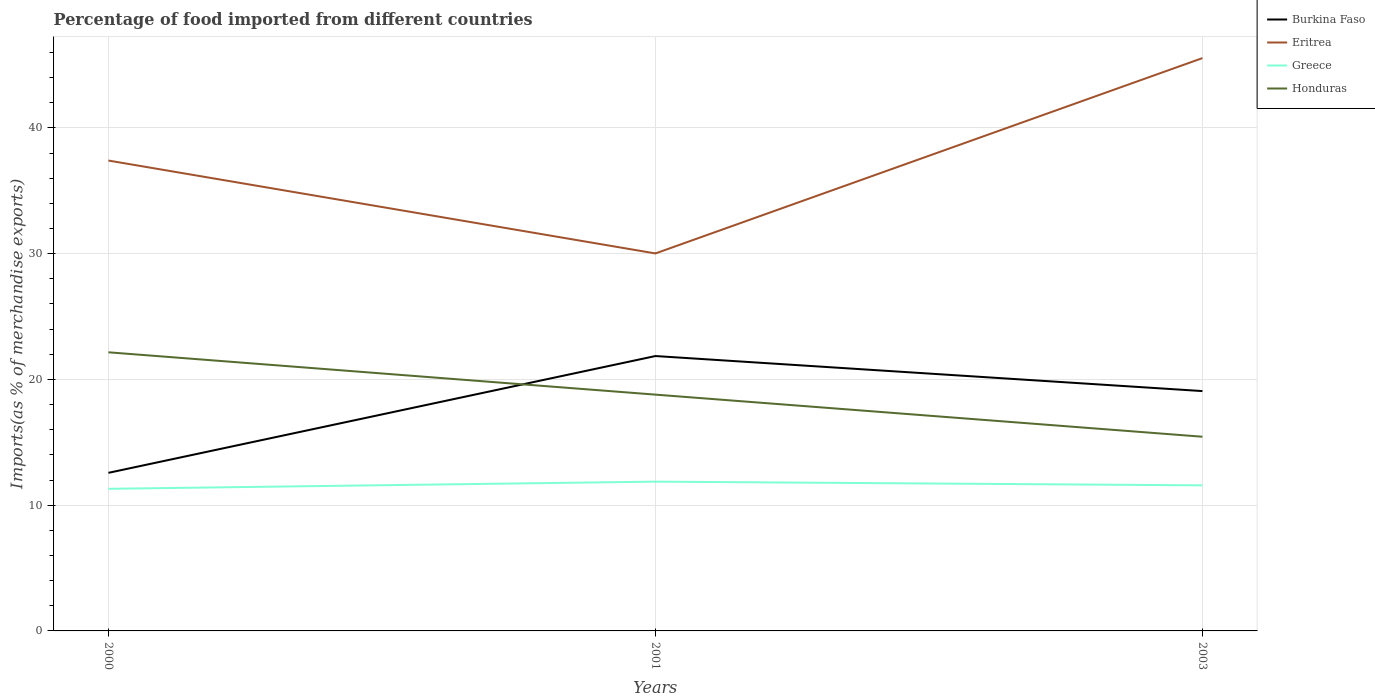Is the number of lines equal to the number of legend labels?
Provide a short and direct response. Yes. Across all years, what is the maximum percentage of imports to different countries in Greece?
Your answer should be very brief. 11.3. What is the total percentage of imports to different countries in Burkina Faso in the graph?
Your response must be concise. 2.79. What is the difference between the highest and the second highest percentage of imports to different countries in Honduras?
Provide a short and direct response. 6.71. How many years are there in the graph?
Offer a terse response. 3. Does the graph contain any zero values?
Your response must be concise. No. How many legend labels are there?
Make the answer very short. 4. How are the legend labels stacked?
Provide a succinct answer. Vertical. What is the title of the graph?
Provide a succinct answer. Percentage of food imported from different countries. Does "Suriname" appear as one of the legend labels in the graph?
Give a very brief answer. No. What is the label or title of the Y-axis?
Your response must be concise. Imports(as % of merchandise exports). What is the Imports(as % of merchandise exports) of Burkina Faso in 2000?
Make the answer very short. 12.57. What is the Imports(as % of merchandise exports) in Eritrea in 2000?
Provide a short and direct response. 37.41. What is the Imports(as % of merchandise exports) of Greece in 2000?
Your answer should be very brief. 11.3. What is the Imports(as % of merchandise exports) of Honduras in 2000?
Provide a short and direct response. 22.16. What is the Imports(as % of merchandise exports) in Burkina Faso in 2001?
Your response must be concise. 21.86. What is the Imports(as % of merchandise exports) in Eritrea in 2001?
Offer a very short reply. 30.02. What is the Imports(as % of merchandise exports) of Greece in 2001?
Your response must be concise. 11.87. What is the Imports(as % of merchandise exports) of Honduras in 2001?
Make the answer very short. 18.79. What is the Imports(as % of merchandise exports) in Burkina Faso in 2003?
Keep it short and to the point. 19.07. What is the Imports(as % of merchandise exports) of Eritrea in 2003?
Your answer should be compact. 45.56. What is the Imports(as % of merchandise exports) in Greece in 2003?
Keep it short and to the point. 11.58. What is the Imports(as % of merchandise exports) in Honduras in 2003?
Ensure brevity in your answer.  15.44. Across all years, what is the maximum Imports(as % of merchandise exports) of Burkina Faso?
Offer a terse response. 21.86. Across all years, what is the maximum Imports(as % of merchandise exports) in Eritrea?
Keep it short and to the point. 45.56. Across all years, what is the maximum Imports(as % of merchandise exports) in Greece?
Ensure brevity in your answer.  11.87. Across all years, what is the maximum Imports(as % of merchandise exports) of Honduras?
Your answer should be very brief. 22.16. Across all years, what is the minimum Imports(as % of merchandise exports) in Burkina Faso?
Provide a short and direct response. 12.57. Across all years, what is the minimum Imports(as % of merchandise exports) in Eritrea?
Give a very brief answer. 30.02. Across all years, what is the minimum Imports(as % of merchandise exports) in Greece?
Provide a succinct answer. 11.3. Across all years, what is the minimum Imports(as % of merchandise exports) of Honduras?
Offer a terse response. 15.44. What is the total Imports(as % of merchandise exports) in Burkina Faso in the graph?
Offer a very short reply. 53.51. What is the total Imports(as % of merchandise exports) in Eritrea in the graph?
Offer a very short reply. 112.98. What is the total Imports(as % of merchandise exports) of Greece in the graph?
Your answer should be very brief. 34.75. What is the total Imports(as % of merchandise exports) in Honduras in the graph?
Provide a succinct answer. 56.4. What is the difference between the Imports(as % of merchandise exports) of Burkina Faso in 2000 and that in 2001?
Provide a succinct answer. -9.29. What is the difference between the Imports(as % of merchandise exports) in Eritrea in 2000 and that in 2001?
Make the answer very short. 7.39. What is the difference between the Imports(as % of merchandise exports) in Greece in 2000 and that in 2001?
Ensure brevity in your answer.  -0.57. What is the difference between the Imports(as % of merchandise exports) of Honduras in 2000 and that in 2001?
Provide a short and direct response. 3.37. What is the difference between the Imports(as % of merchandise exports) of Burkina Faso in 2000 and that in 2003?
Make the answer very short. -6.5. What is the difference between the Imports(as % of merchandise exports) in Eritrea in 2000 and that in 2003?
Provide a succinct answer. -8.15. What is the difference between the Imports(as % of merchandise exports) of Greece in 2000 and that in 2003?
Your answer should be compact. -0.28. What is the difference between the Imports(as % of merchandise exports) in Honduras in 2000 and that in 2003?
Ensure brevity in your answer.  6.71. What is the difference between the Imports(as % of merchandise exports) in Burkina Faso in 2001 and that in 2003?
Make the answer very short. 2.79. What is the difference between the Imports(as % of merchandise exports) of Eritrea in 2001 and that in 2003?
Keep it short and to the point. -15.53. What is the difference between the Imports(as % of merchandise exports) of Greece in 2001 and that in 2003?
Offer a very short reply. 0.3. What is the difference between the Imports(as % of merchandise exports) of Honduras in 2001 and that in 2003?
Give a very brief answer. 3.35. What is the difference between the Imports(as % of merchandise exports) in Burkina Faso in 2000 and the Imports(as % of merchandise exports) in Eritrea in 2001?
Offer a terse response. -17.45. What is the difference between the Imports(as % of merchandise exports) of Burkina Faso in 2000 and the Imports(as % of merchandise exports) of Greece in 2001?
Provide a succinct answer. 0.7. What is the difference between the Imports(as % of merchandise exports) in Burkina Faso in 2000 and the Imports(as % of merchandise exports) in Honduras in 2001?
Provide a succinct answer. -6.22. What is the difference between the Imports(as % of merchandise exports) in Eritrea in 2000 and the Imports(as % of merchandise exports) in Greece in 2001?
Provide a short and direct response. 25.54. What is the difference between the Imports(as % of merchandise exports) of Eritrea in 2000 and the Imports(as % of merchandise exports) of Honduras in 2001?
Offer a very short reply. 18.62. What is the difference between the Imports(as % of merchandise exports) of Greece in 2000 and the Imports(as % of merchandise exports) of Honduras in 2001?
Offer a terse response. -7.49. What is the difference between the Imports(as % of merchandise exports) of Burkina Faso in 2000 and the Imports(as % of merchandise exports) of Eritrea in 2003?
Provide a succinct answer. -32.98. What is the difference between the Imports(as % of merchandise exports) of Burkina Faso in 2000 and the Imports(as % of merchandise exports) of Honduras in 2003?
Keep it short and to the point. -2.87. What is the difference between the Imports(as % of merchandise exports) of Eritrea in 2000 and the Imports(as % of merchandise exports) of Greece in 2003?
Your answer should be very brief. 25.83. What is the difference between the Imports(as % of merchandise exports) of Eritrea in 2000 and the Imports(as % of merchandise exports) of Honduras in 2003?
Your answer should be very brief. 21.96. What is the difference between the Imports(as % of merchandise exports) in Greece in 2000 and the Imports(as % of merchandise exports) in Honduras in 2003?
Your response must be concise. -4.14. What is the difference between the Imports(as % of merchandise exports) of Burkina Faso in 2001 and the Imports(as % of merchandise exports) of Eritrea in 2003?
Your response must be concise. -23.69. What is the difference between the Imports(as % of merchandise exports) of Burkina Faso in 2001 and the Imports(as % of merchandise exports) of Greece in 2003?
Ensure brevity in your answer.  10.28. What is the difference between the Imports(as % of merchandise exports) in Burkina Faso in 2001 and the Imports(as % of merchandise exports) in Honduras in 2003?
Ensure brevity in your answer.  6.42. What is the difference between the Imports(as % of merchandise exports) in Eritrea in 2001 and the Imports(as % of merchandise exports) in Greece in 2003?
Your answer should be compact. 18.44. What is the difference between the Imports(as % of merchandise exports) of Eritrea in 2001 and the Imports(as % of merchandise exports) of Honduras in 2003?
Your answer should be compact. 14.58. What is the difference between the Imports(as % of merchandise exports) in Greece in 2001 and the Imports(as % of merchandise exports) in Honduras in 2003?
Ensure brevity in your answer.  -3.57. What is the average Imports(as % of merchandise exports) in Burkina Faso per year?
Your answer should be compact. 17.84. What is the average Imports(as % of merchandise exports) of Eritrea per year?
Offer a terse response. 37.66. What is the average Imports(as % of merchandise exports) of Greece per year?
Provide a succinct answer. 11.58. What is the average Imports(as % of merchandise exports) in Honduras per year?
Your answer should be very brief. 18.8. In the year 2000, what is the difference between the Imports(as % of merchandise exports) in Burkina Faso and Imports(as % of merchandise exports) in Eritrea?
Offer a very short reply. -24.84. In the year 2000, what is the difference between the Imports(as % of merchandise exports) of Burkina Faso and Imports(as % of merchandise exports) of Greece?
Give a very brief answer. 1.27. In the year 2000, what is the difference between the Imports(as % of merchandise exports) in Burkina Faso and Imports(as % of merchandise exports) in Honduras?
Offer a very short reply. -9.59. In the year 2000, what is the difference between the Imports(as % of merchandise exports) in Eritrea and Imports(as % of merchandise exports) in Greece?
Make the answer very short. 26.11. In the year 2000, what is the difference between the Imports(as % of merchandise exports) of Eritrea and Imports(as % of merchandise exports) of Honduras?
Keep it short and to the point. 15.25. In the year 2000, what is the difference between the Imports(as % of merchandise exports) in Greece and Imports(as % of merchandise exports) in Honduras?
Ensure brevity in your answer.  -10.86. In the year 2001, what is the difference between the Imports(as % of merchandise exports) of Burkina Faso and Imports(as % of merchandise exports) of Eritrea?
Offer a very short reply. -8.16. In the year 2001, what is the difference between the Imports(as % of merchandise exports) in Burkina Faso and Imports(as % of merchandise exports) in Greece?
Provide a short and direct response. 9.99. In the year 2001, what is the difference between the Imports(as % of merchandise exports) of Burkina Faso and Imports(as % of merchandise exports) of Honduras?
Offer a terse response. 3.07. In the year 2001, what is the difference between the Imports(as % of merchandise exports) in Eritrea and Imports(as % of merchandise exports) in Greece?
Your answer should be very brief. 18.15. In the year 2001, what is the difference between the Imports(as % of merchandise exports) of Eritrea and Imports(as % of merchandise exports) of Honduras?
Offer a very short reply. 11.23. In the year 2001, what is the difference between the Imports(as % of merchandise exports) in Greece and Imports(as % of merchandise exports) in Honduras?
Offer a very short reply. -6.92. In the year 2003, what is the difference between the Imports(as % of merchandise exports) of Burkina Faso and Imports(as % of merchandise exports) of Eritrea?
Your answer should be very brief. -26.48. In the year 2003, what is the difference between the Imports(as % of merchandise exports) of Burkina Faso and Imports(as % of merchandise exports) of Greece?
Your answer should be compact. 7.5. In the year 2003, what is the difference between the Imports(as % of merchandise exports) in Burkina Faso and Imports(as % of merchandise exports) in Honduras?
Your answer should be very brief. 3.63. In the year 2003, what is the difference between the Imports(as % of merchandise exports) in Eritrea and Imports(as % of merchandise exports) in Greece?
Offer a very short reply. 33.98. In the year 2003, what is the difference between the Imports(as % of merchandise exports) in Eritrea and Imports(as % of merchandise exports) in Honduras?
Your response must be concise. 30.11. In the year 2003, what is the difference between the Imports(as % of merchandise exports) in Greece and Imports(as % of merchandise exports) in Honduras?
Offer a very short reply. -3.87. What is the ratio of the Imports(as % of merchandise exports) of Burkina Faso in 2000 to that in 2001?
Offer a very short reply. 0.58. What is the ratio of the Imports(as % of merchandise exports) in Eritrea in 2000 to that in 2001?
Provide a succinct answer. 1.25. What is the ratio of the Imports(as % of merchandise exports) in Greece in 2000 to that in 2001?
Your answer should be very brief. 0.95. What is the ratio of the Imports(as % of merchandise exports) in Honduras in 2000 to that in 2001?
Ensure brevity in your answer.  1.18. What is the ratio of the Imports(as % of merchandise exports) of Burkina Faso in 2000 to that in 2003?
Your answer should be compact. 0.66. What is the ratio of the Imports(as % of merchandise exports) of Eritrea in 2000 to that in 2003?
Offer a very short reply. 0.82. What is the ratio of the Imports(as % of merchandise exports) of Greece in 2000 to that in 2003?
Make the answer very short. 0.98. What is the ratio of the Imports(as % of merchandise exports) of Honduras in 2000 to that in 2003?
Keep it short and to the point. 1.43. What is the ratio of the Imports(as % of merchandise exports) of Burkina Faso in 2001 to that in 2003?
Provide a short and direct response. 1.15. What is the ratio of the Imports(as % of merchandise exports) in Eritrea in 2001 to that in 2003?
Make the answer very short. 0.66. What is the ratio of the Imports(as % of merchandise exports) of Greece in 2001 to that in 2003?
Give a very brief answer. 1.03. What is the ratio of the Imports(as % of merchandise exports) in Honduras in 2001 to that in 2003?
Offer a very short reply. 1.22. What is the difference between the highest and the second highest Imports(as % of merchandise exports) in Burkina Faso?
Your answer should be compact. 2.79. What is the difference between the highest and the second highest Imports(as % of merchandise exports) in Eritrea?
Make the answer very short. 8.15. What is the difference between the highest and the second highest Imports(as % of merchandise exports) of Greece?
Provide a short and direct response. 0.3. What is the difference between the highest and the second highest Imports(as % of merchandise exports) in Honduras?
Make the answer very short. 3.37. What is the difference between the highest and the lowest Imports(as % of merchandise exports) of Burkina Faso?
Your answer should be compact. 9.29. What is the difference between the highest and the lowest Imports(as % of merchandise exports) in Eritrea?
Your response must be concise. 15.53. What is the difference between the highest and the lowest Imports(as % of merchandise exports) of Greece?
Keep it short and to the point. 0.57. What is the difference between the highest and the lowest Imports(as % of merchandise exports) of Honduras?
Ensure brevity in your answer.  6.71. 